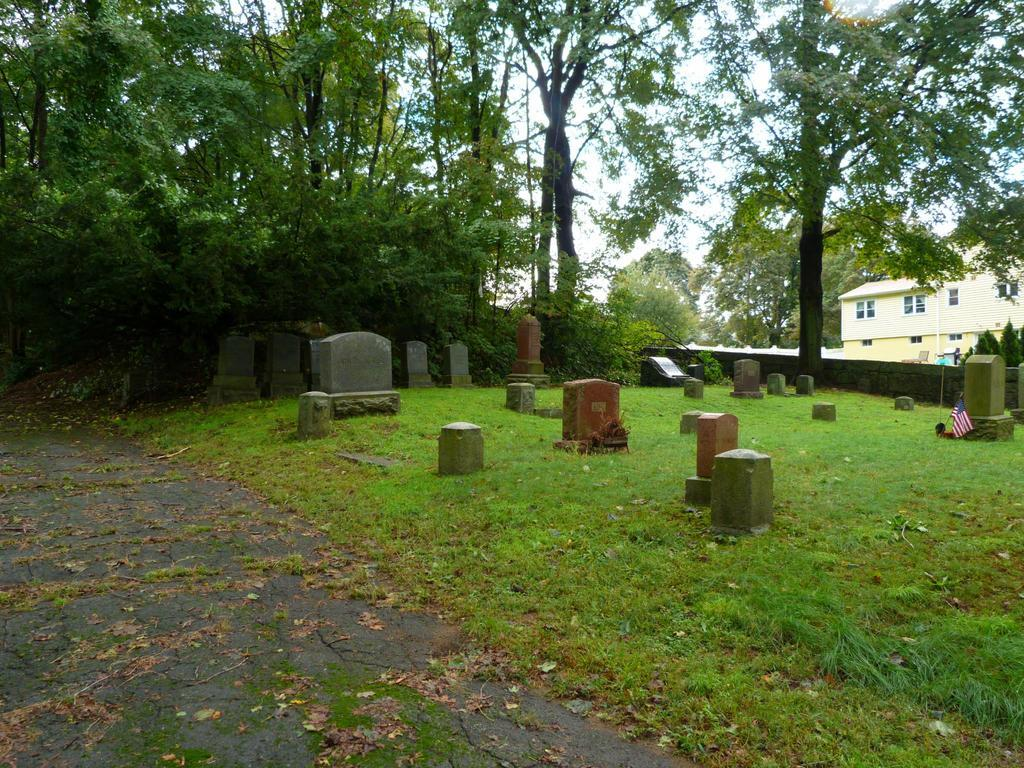What type of vegetation can be seen in the image? There is grass in the image. What is the primary setting of the image? There is a graveyard in the image. What other natural elements are present in the image? There are trees in the image. What structures can be seen in the image? There is a wall and a building in the image. What is attached to the wall in the image? There is a flag in the image. What can be seen in the background of the image? The sky is visible in the background of the image. How much meat is hanging from the trees in the image? There is no meat hanging from the trees in the image; it is a graveyard with trees and other structures. 